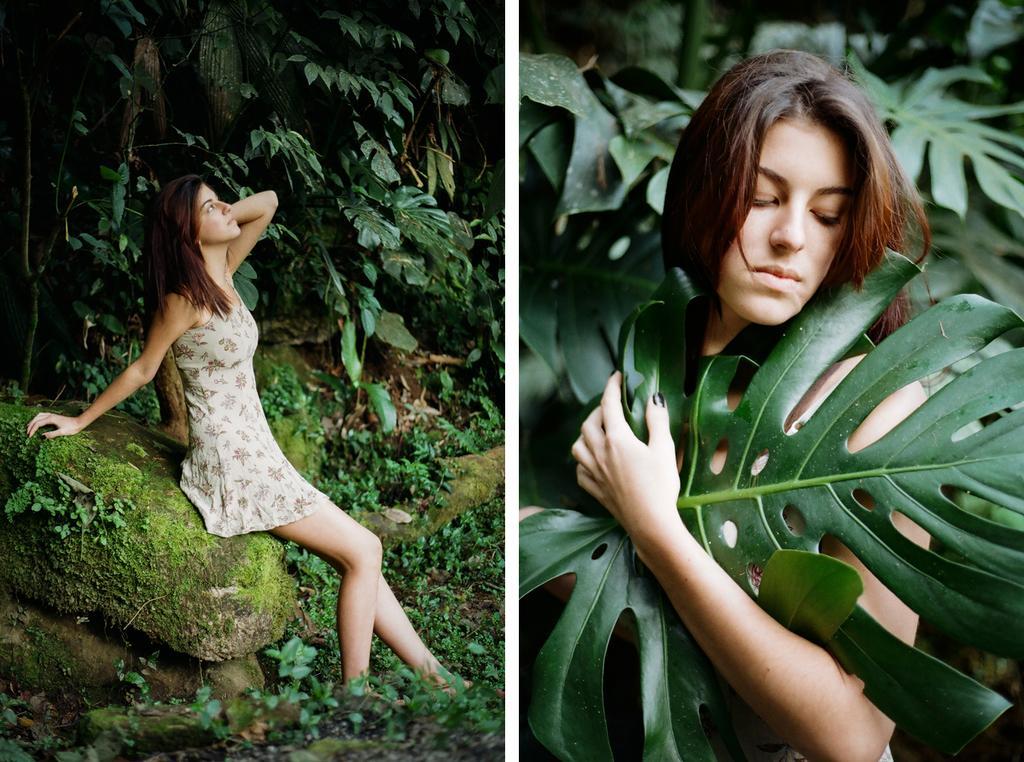How would you summarize this image in a sentence or two? In this image i can see a two women, on the left side woman she is sitting on stone and at the top I can see trees on the left side. 